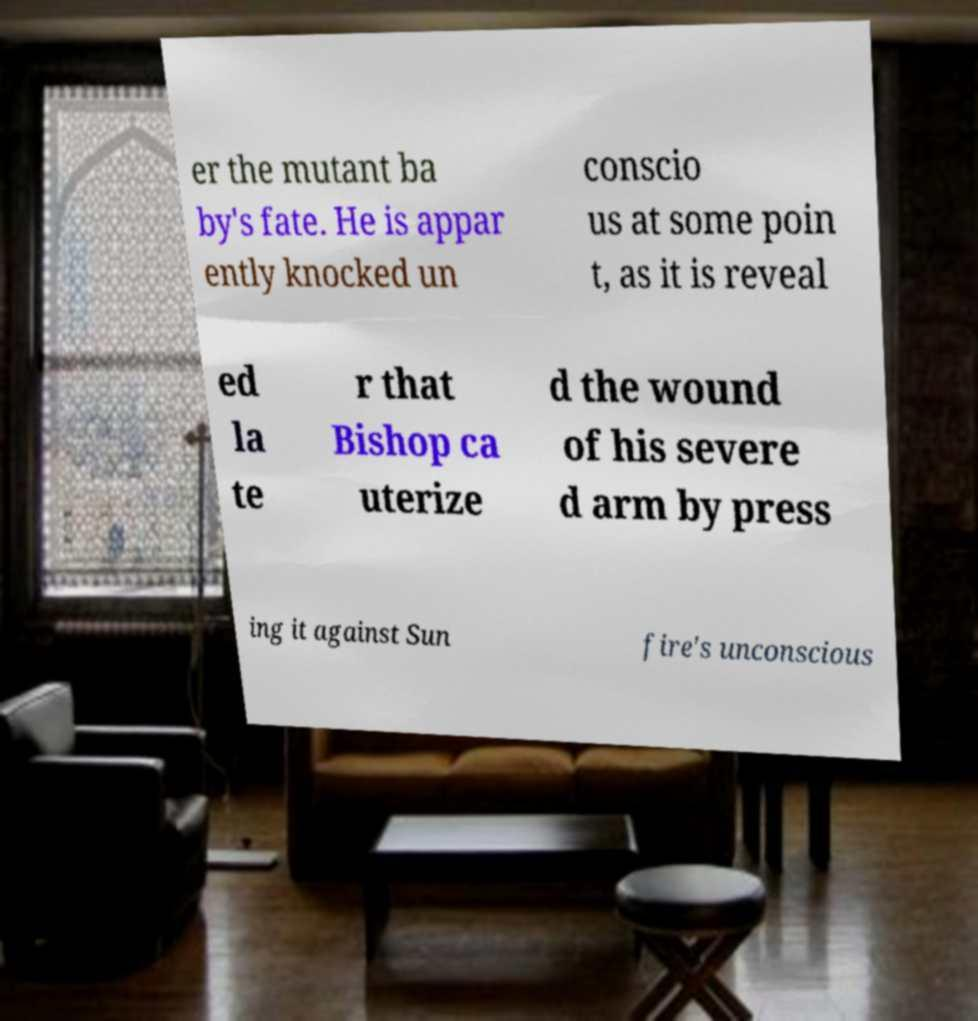What messages or text are displayed in this image? I need them in a readable, typed format. er the mutant ba by's fate. He is appar ently knocked un conscio us at some poin t, as it is reveal ed la te r that Bishop ca uterize d the wound of his severe d arm by press ing it against Sun fire's unconscious 